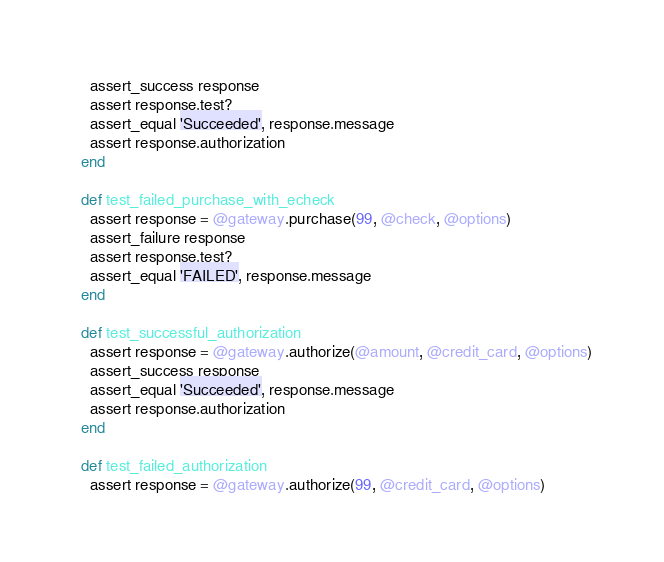Convert code to text. <code><loc_0><loc_0><loc_500><loc_500><_Ruby_>    assert_success response
    assert response.test?
    assert_equal 'Succeeded', response.message
    assert response.authorization
  end

  def test_failed_purchase_with_echeck
    assert response = @gateway.purchase(99, @check, @options)
    assert_failure response
    assert response.test?
    assert_equal 'FAILED', response.message
  end

  def test_successful_authorization
    assert response = @gateway.authorize(@amount, @credit_card, @options)
    assert_success response
    assert_equal 'Succeeded', response.message
    assert response.authorization
  end

  def test_failed_authorization
    assert response = @gateway.authorize(99, @credit_card, @options)</code> 